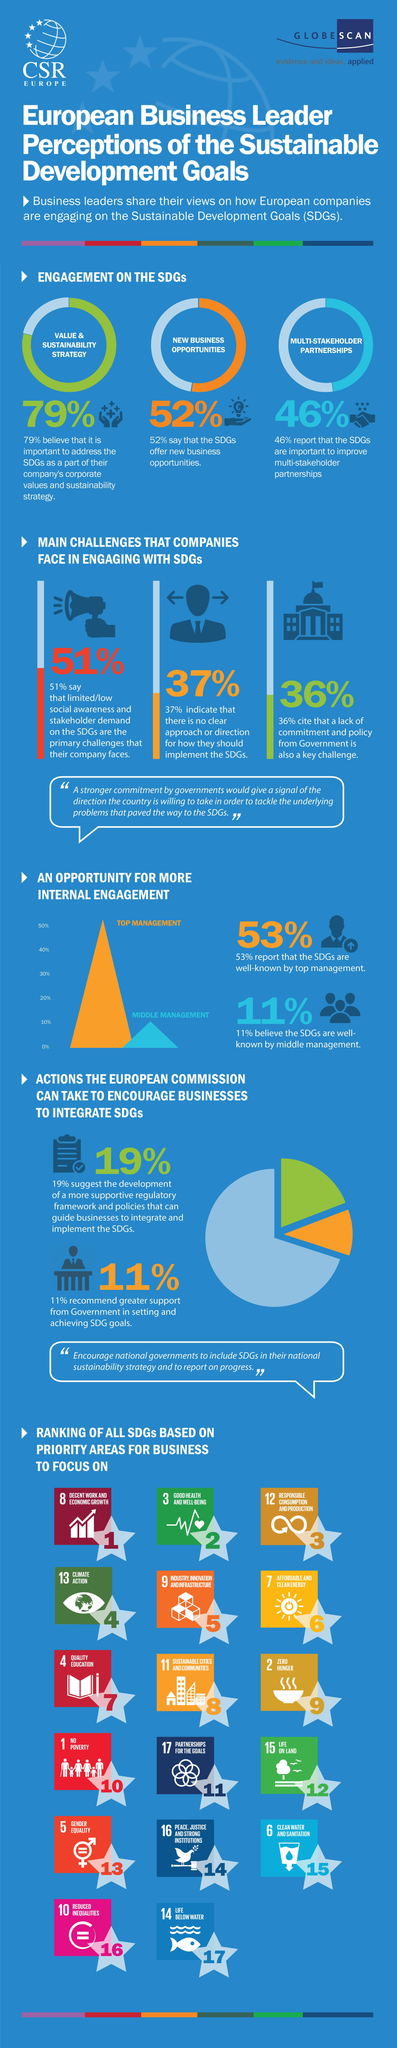How many feel that SDG's lack clarity on the goals committed?
Answer the question with a short phrase. 37% What is the percentage of new opportunities, 79%, 46%, or  52%? 52% 